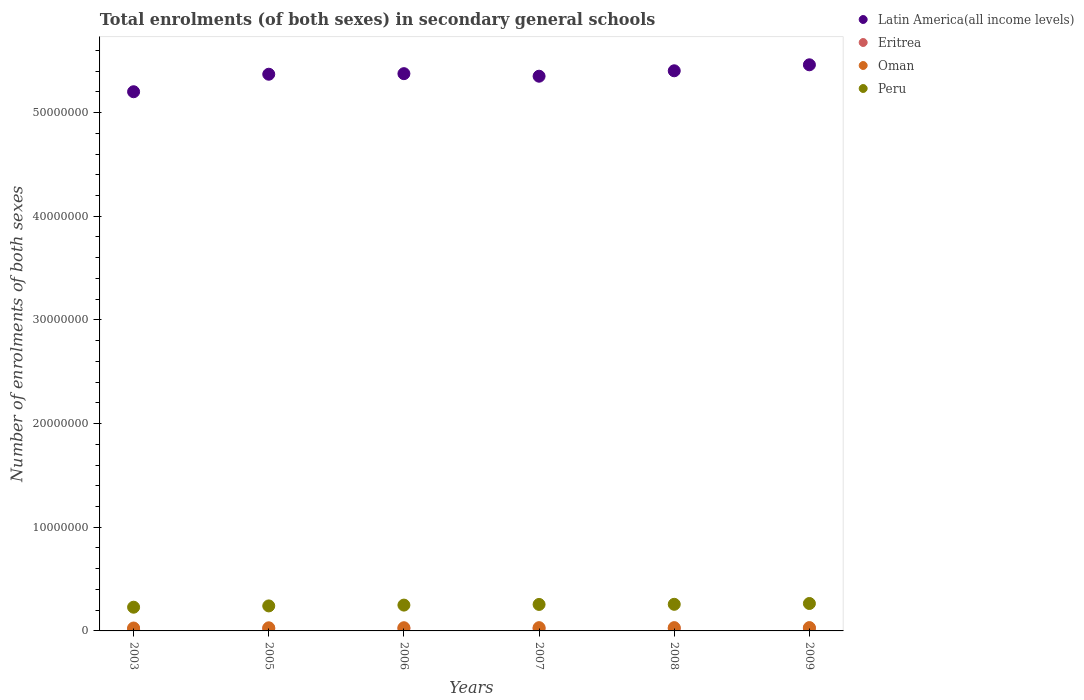How many different coloured dotlines are there?
Offer a very short reply. 4. Is the number of dotlines equal to the number of legend labels?
Provide a succinct answer. Yes. What is the number of enrolments in secondary schools in Eritrea in 2003?
Keep it short and to the point. 1.59e+05. Across all years, what is the maximum number of enrolments in secondary schools in Oman?
Make the answer very short. 3.22e+05. Across all years, what is the minimum number of enrolments in secondary schools in Peru?
Ensure brevity in your answer.  2.29e+06. In which year was the number of enrolments in secondary schools in Latin America(all income levels) maximum?
Offer a terse response. 2009. In which year was the number of enrolments in secondary schools in Latin America(all income levels) minimum?
Offer a terse response. 2003. What is the total number of enrolments in secondary schools in Eritrea in the graph?
Offer a terse response. 1.29e+06. What is the difference between the number of enrolments in secondary schools in Peru in 2003 and that in 2007?
Keep it short and to the point. -2.67e+05. What is the difference between the number of enrolments in secondary schools in Peru in 2006 and the number of enrolments in secondary schools in Oman in 2003?
Offer a very short reply. 2.21e+06. What is the average number of enrolments in secondary schools in Oman per year?
Ensure brevity in your answer.  3.07e+05. In the year 2008, what is the difference between the number of enrolments in secondary schools in Latin America(all income levels) and number of enrolments in secondary schools in Peru?
Your answer should be compact. 5.15e+07. What is the ratio of the number of enrolments in secondary schools in Oman in 2006 to that in 2007?
Your answer should be very brief. 0.98. Is the number of enrolments in secondary schools in Eritrea in 2006 less than that in 2008?
Make the answer very short. Yes. What is the difference between the highest and the second highest number of enrolments in secondary schools in Oman?
Offer a terse response. 3854. What is the difference between the highest and the lowest number of enrolments in secondary schools in Latin America(all income levels)?
Provide a succinct answer. 2.60e+06. In how many years, is the number of enrolments in secondary schools in Oman greater than the average number of enrolments in secondary schools in Oman taken over all years?
Provide a short and direct response. 4. Is it the case that in every year, the sum of the number of enrolments in secondary schools in Oman and number of enrolments in secondary schools in Eritrea  is greater than the sum of number of enrolments in secondary schools in Peru and number of enrolments in secondary schools in Latin America(all income levels)?
Give a very brief answer. No. Is it the case that in every year, the sum of the number of enrolments in secondary schools in Latin America(all income levels) and number of enrolments in secondary schools in Peru  is greater than the number of enrolments in secondary schools in Oman?
Offer a very short reply. Yes. Does the number of enrolments in secondary schools in Latin America(all income levels) monotonically increase over the years?
Provide a succinct answer. No. How many dotlines are there?
Your response must be concise. 4. Are the values on the major ticks of Y-axis written in scientific E-notation?
Your answer should be very brief. No. Does the graph contain any zero values?
Ensure brevity in your answer.  No. Does the graph contain grids?
Give a very brief answer. No. How are the legend labels stacked?
Make the answer very short. Vertical. What is the title of the graph?
Your response must be concise. Total enrolments (of both sexes) in secondary general schools. What is the label or title of the X-axis?
Provide a succinct answer. Years. What is the label or title of the Y-axis?
Provide a short and direct response. Number of enrolments of both sexes. What is the Number of enrolments of both sexes of Latin America(all income levels) in 2003?
Keep it short and to the point. 5.20e+07. What is the Number of enrolments of both sexes of Eritrea in 2003?
Offer a terse response. 1.59e+05. What is the Number of enrolments of both sexes of Oman in 2003?
Give a very brief answer. 2.79e+05. What is the Number of enrolments of both sexes of Peru in 2003?
Make the answer very short. 2.29e+06. What is the Number of enrolments of both sexes in Latin America(all income levels) in 2005?
Make the answer very short. 5.37e+07. What is the Number of enrolments of both sexes in Eritrea in 2005?
Ensure brevity in your answer.  2.15e+05. What is the Number of enrolments of both sexes in Oman in 2005?
Your answer should be very brief. 3.02e+05. What is the Number of enrolments of both sexes in Peru in 2005?
Give a very brief answer. 2.41e+06. What is the Number of enrolments of both sexes of Latin America(all income levels) in 2006?
Make the answer very short. 5.38e+07. What is the Number of enrolments of both sexes of Eritrea in 2006?
Offer a very short reply. 2.26e+05. What is the Number of enrolments of both sexes in Oman in 2006?
Provide a succinct answer. 3.09e+05. What is the Number of enrolments of both sexes in Peru in 2006?
Your answer should be compact. 2.49e+06. What is the Number of enrolments of both sexes of Latin America(all income levels) in 2007?
Your answer should be compact. 5.35e+07. What is the Number of enrolments of both sexes in Eritrea in 2007?
Offer a very short reply. 2.17e+05. What is the Number of enrolments of both sexes in Oman in 2007?
Provide a succinct answer. 3.16e+05. What is the Number of enrolments of both sexes of Peru in 2007?
Provide a short and direct response. 2.55e+06. What is the Number of enrolments of both sexes in Latin America(all income levels) in 2008?
Your response must be concise. 5.40e+07. What is the Number of enrolments of both sexes of Eritrea in 2008?
Offer a very short reply. 2.27e+05. What is the Number of enrolments of both sexes of Oman in 2008?
Provide a short and direct response. 3.18e+05. What is the Number of enrolments of both sexes of Peru in 2008?
Provide a succinct answer. 2.57e+06. What is the Number of enrolments of both sexes of Latin America(all income levels) in 2009?
Ensure brevity in your answer.  5.46e+07. What is the Number of enrolments of both sexes of Eritrea in 2009?
Provide a short and direct response. 2.41e+05. What is the Number of enrolments of both sexes in Oman in 2009?
Your response must be concise. 3.22e+05. What is the Number of enrolments of both sexes of Peru in 2009?
Give a very brief answer. 2.65e+06. Across all years, what is the maximum Number of enrolments of both sexes in Latin America(all income levels)?
Provide a succinct answer. 5.46e+07. Across all years, what is the maximum Number of enrolments of both sexes in Eritrea?
Provide a short and direct response. 2.41e+05. Across all years, what is the maximum Number of enrolments of both sexes in Oman?
Ensure brevity in your answer.  3.22e+05. Across all years, what is the maximum Number of enrolments of both sexes of Peru?
Provide a short and direct response. 2.65e+06. Across all years, what is the minimum Number of enrolments of both sexes in Latin America(all income levels)?
Your answer should be compact. 5.20e+07. Across all years, what is the minimum Number of enrolments of both sexes of Eritrea?
Give a very brief answer. 1.59e+05. Across all years, what is the minimum Number of enrolments of both sexes of Oman?
Give a very brief answer. 2.79e+05. Across all years, what is the minimum Number of enrolments of both sexes of Peru?
Keep it short and to the point. 2.29e+06. What is the total Number of enrolments of both sexes of Latin America(all income levels) in the graph?
Provide a succinct answer. 3.22e+08. What is the total Number of enrolments of both sexes of Eritrea in the graph?
Ensure brevity in your answer.  1.29e+06. What is the total Number of enrolments of both sexes in Oman in the graph?
Offer a very short reply. 1.84e+06. What is the total Number of enrolments of both sexes in Peru in the graph?
Your answer should be very brief. 1.50e+07. What is the difference between the Number of enrolments of both sexes of Latin America(all income levels) in 2003 and that in 2005?
Your response must be concise. -1.69e+06. What is the difference between the Number of enrolments of both sexes of Eritrea in 2003 and that in 2005?
Offer a terse response. -5.56e+04. What is the difference between the Number of enrolments of both sexes in Oman in 2003 and that in 2005?
Make the answer very short. -2.23e+04. What is the difference between the Number of enrolments of both sexes in Peru in 2003 and that in 2005?
Offer a very short reply. -1.25e+05. What is the difference between the Number of enrolments of both sexes in Latin America(all income levels) in 2003 and that in 2006?
Provide a short and direct response. -1.74e+06. What is the difference between the Number of enrolments of both sexes in Eritrea in 2003 and that in 2006?
Your answer should be compact. -6.63e+04. What is the difference between the Number of enrolments of both sexes in Oman in 2003 and that in 2006?
Your answer should be very brief. -2.92e+04. What is the difference between the Number of enrolments of both sexes in Peru in 2003 and that in 2006?
Provide a succinct answer. -2.04e+05. What is the difference between the Number of enrolments of both sexes of Latin America(all income levels) in 2003 and that in 2007?
Offer a very short reply. -1.50e+06. What is the difference between the Number of enrolments of both sexes of Eritrea in 2003 and that in 2007?
Provide a succinct answer. -5.74e+04. What is the difference between the Number of enrolments of both sexes in Oman in 2003 and that in 2007?
Your answer should be very brief. -3.67e+04. What is the difference between the Number of enrolments of both sexes of Peru in 2003 and that in 2007?
Give a very brief answer. -2.67e+05. What is the difference between the Number of enrolments of both sexes of Latin America(all income levels) in 2003 and that in 2008?
Your response must be concise. -2.02e+06. What is the difference between the Number of enrolments of both sexes of Eritrea in 2003 and that in 2008?
Your answer should be very brief. -6.80e+04. What is the difference between the Number of enrolments of both sexes in Oman in 2003 and that in 2008?
Give a very brief answer. -3.85e+04. What is the difference between the Number of enrolments of both sexes of Peru in 2003 and that in 2008?
Ensure brevity in your answer.  -2.79e+05. What is the difference between the Number of enrolments of both sexes of Latin America(all income levels) in 2003 and that in 2009?
Provide a short and direct response. -2.60e+06. What is the difference between the Number of enrolments of both sexes of Eritrea in 2003 and that in 2009?
Your response must be concise. -8.14e+04. What is the difference between the Number of enrolments of both sexes in Oman in 2003 and that in 2009?
Offer a terse response. -4.24e+04. What is the difference between the Number of enrolments of both sexes of Peru in 2003 and that in 2009?
Provide a short and direct response. -3.58e+05. What is the difference between the Number of enrolments of both sexes of Latin America(all income levels) in 2005 and that in 2006?
Offer a terse response. -5.54e+04. What is the difference between the Number of enrolments of both sexes in Eritrea in 2005 and that in 2006?
Offer a terse response. -1.06e+04. What is the difference between the Number of enrolments of both sexes in Oman in 2005 and that in 2006?
Make the answer very short. -6940. What is the difference between the Number of enrolments of both sexes of Peru in 2005 and that in 2006?
Make the answer very short. -7.90e+04. What is the difference between the Number of enrolments of both sexes in Latin America(all income levels) in 2005 and that in 2007?
Your response must be concise. 1.91e+05. What is the difference between the Number of enrolments of both sexes of Eritrea in 2005 and that in 2007?
Your answer should be very brief. -1801. What is the difference between the Number of enrolments of both sexes in Oman in 2005 and that in 2007?
Provide a short and direct response. -1.45e+04. What is the difference between the Number of enrolments of both sexes of Peru in 2005 and that in 2007?
Your answer should be very brief. -1.42e+05. What is the difference between the Number of enrolments of both sexes of Latin America(all income levels) in 2005 and that in 2008?
Offer a very short reply. -3.32e+05. What is the difference between the Number of enrolments of both sexes of Eritrea in 2005 and that in 2008?
Keep it short and to the point. -1.24e+04. What is the difference between the Number of enrolments of both sexes in Oman in 2005 and that in 2008?
Your response must be concise. -1.62e+04. What is the difference between the Number of enrolments of both sexes in Peru in 2005 and that in 2008?
Keep it short and to the point. -1.54e+05. What is the difference between the Number of enrolments of both sexes of Latin America(all income levels) in 2005 and that in 2009?
Provide a succinct answer. -9.10e+05. What is the difference between the Number of enrolments of both sexes of Eritrea in 2005 and that in 2009?
Ensure brevity in your answer.  -2.58e+04. What is the difference between the Number of enrolments of both sexes of Oman in 2005 and that in 2009?
Make the answer very short. -2.01e+04. What is the difference between the Number of enrolments of both sexes in Peru in 2005 and that in 2009?
Offer a very short reply. -2.33e+05. What is the difference between the Number of enrolments of both sexes of Latin America(all income levels) in 2006 and that in 2007?
Your response must be concise. 2.46e+05. What is the difference between the Number of enrolments of both sexes of Eritrea in 2006 and that in 2007?
Provide a succinct answer. 8845. What is the difference between the Number of enrolments of both sexes in Oman in 2006 and that in 2007?
Ensure brevity in your answer.  -7511. What is the difference between the Number of enrolments of both sexes in Peru in 2006 and that in 2007?
Provide a succinct answer. -6.28e+04. What is the difference between the Number of enrolments of both sexes in Latin America(all income levels) in 2006 and that in 2008?
Give a very brief answer. -2.77e+05. What is the difference between the Number of enrolments of both sexes of Eritrea in 2006 and that in 2008?
Offer a terse response. -1716. What is the difference between the Number of enrolments of both sexes of Oman in 2006 and that in 2008?
Offer a very short reply. -9308. What is the difference between the Number of enrolments of both sexes of Peru in 2006 and that in 2008?
Offer a very short reply. -7.54e+04. What is the difference between the Number of enrolments of both sexes in Latin America(all income levels) in 2006 and that in 2009?
Make the answer very short. -8.55e+05. What is the difference between the Number of enrolments of both sexes of Eritrea in 2006 and that in 2009?
Offer a terse response. -1.52e+04. What is the difference between the Number of enrolments of both sexes of Oman in 2006 and that in 2009?
Give a very brief answer. -1.32e+04. What is the difference between the Number of enrolments of both sexes in Peru in 2006 and that in 2009?
Make the answer very short. -1.54e+05. What is the difference between the Number of enrolments of both sexes in Latin America(all income levels) in 2007 and that in 2008?
Provide a short and direct response. -5.23e+05. What is the difference between the Number of enrolments of both sexes in Eritrea in 2007 and that in 2008?
Ensure brevity in your answer.  -1.06e+04. What is the difference between the Number of enrolments of both sexes of Oman in 2007 and that in 2008?
Your answer should be compact. -1797. What is the difference between the Number of enrolments of both sexes in Peru in 2007 and that in 2008?
Make the answer very short. -1.26e+04. What is the difference between the Number of enrolments of both sexes of Latin America(all income levels) in 2007 and that in 2009?
Your answer should be very brief. -1.10e+06. What is the difference between the Number of enrolments of both sexes in Eritrea in 2007 and that in 2009?
Give a very brief answer. -2.40e+04. What is the difference between the Number of enrolments of both sexes of Oman in 2007 and that in 2009?
Offer a terse response. -5651. What is the difference between the Number of enrolments of both sexes in Peru in 2007 and that in 2009?
Offer a very short reply. -9.13e+04. What is the difference between the Number of enrolments of both sexes in Latin America(all income levels) in 2008 and that in 2009?
Your answer should be compact. -5.78e+05. What is the difference between the Number of enrolments of both sexes of Eritrea in 2008 and that in 2009?
Provide a succinct answer. -1.34e+04. What is the difference between the Number of enrolments of both sexes in Oman in 2008 and that in 2009?
Ensure brevity in your answer.  -3854. What is the difference between the Number of enrolments of both sexes of Peru in 2008 and that in 2009?
Make the answer very short. -7.87e+04. What is the difference between the Number of enrolments of both sexes of Latin America(all income levels) in 2003 and the Number of enrolments of both sexes of Eritrea in 2005?
Make the answer very short. 5.18e+07. What is the difference between the Number of enrolments of both sexes in Latin America(all income levels) in 2003 and the Number of enrolments of both sexes in Oman in 2005?
Your answer should be compact. 5.17e+07. What is the difference between the Number of enrolments of both sexes of Latin America(all income levels) in 2003 and the Number of enrolments of both sexes of Peru in 2005?
Your answer should be compact. 4.96e+07. What is the difference between the Number of enrolments of both sexes in Eritrea in 2003 and the Number of enrolments of both sexes in Oman in 2005?
Ensure brevity in your answer.  -1.42e+05. What is the difference between the Number of enrolments of both sexes of Eritrea in 2003 and the Number of enrolments of both sexes of Peru in 2005?
Your answer should be compact. -2.25e+06. What is the difference between the Number of enrolments of both sexes of Oman in 2003 and the Number of enrolments of both sexes of Peru in 2005?
Ensure brevity in your answer.  -2.13e+06. What is the difference between the Number of enrolments of both sexes of Latin America(all income levels) in 2003 and the Number of enrolments of both sexes of Eritrea in 2006?
Give a very brief answer. 5.18e+07. What is the difference between the Number of enrolments of both sexes of Latin America(all income levels) in 2003 and the Number of enrolments of both sexes of Oman in 2006?
Provide a succinct answer. 5.17e+07. What is the difference between the Number of enrolments of both sexes of Latin America(all income levels) in 2003 and the Number of enrolments of both sexes of Peru in 2006?
Keep it short and to the point. 4.95e+07. What is the difference between the Number of enrolments of both sexes of Eritrea in 2003 and the Number of enrolments of both sexes of Oman in 2006?
Your answer should be compact. -1.49e+05. What is the difference between the Number of enrolments of both sexes of Eritrea in 2003 and the Number of enrolments of both sexes of Peru in 2006?
Offer a very short reply. -2.33e+06. What is the difference between the Number of enrolments of both sexes of Oman in 2003 and the Number of enrolments of both sexes of Peru in 2006?
Make the answer very short. -2.21e+06. What is the difference between the Number of enrolments of both sexes in Latin America(all income levels) in 2003 and the Number of enrolments of both sexes in Eritrea in 2007?
Make the answer very short. 5.18e+07. What is the difference between the Number of enrolments of both sexes of Latin America(all income levels) in 2003 and the Number of enrolments of both sexes of Oman in 2007?
Offer a terse response. 5.17e+07. What is the difference between the Number of enrolments of both sexes in Latin America(all income levels) in 2003 and the Number of enrolments of both sexes in Peru in 2007?
Provide a short and direct response. 4.95e+07. What is the difference between the Number of enrolments of both sexes of Eritrea in 2003 and the Number of enrolments of both sexes of Oman in 2007?
Give a very brief answer. -1.57e+05. What is the difference between the Number of enrolments of both sexes of Eritrea in 2003 and the Number of enrolments of both sexes of Peru in 2007?
Your answer should be compact. -2.39e+06. What is the difference between the Number of enrolments of both sexes in Oman in 2003 and the Number of enrolments of both sexes in Peru in 2007?
Give a very brief answer. -2.27e+06. What is the difference between the Number of enrolments of both sexes of Latin America(all income levels) in 2003 and the Number of enrolments of both sexes of Eritrea in 2008?
Offer a terse response. 5.18e+07. What is the difference between the Number of enrolments of both sexes in Latin America(all income levels) in 2003 and the Number of enrolments of both sexes in Oman in 2008?
Provide a short and direct response. 5.17e+07. What is the difference between the Number of enrolments of both sexes of Latin America(all income levels) in 2003 and the Number of enrolments of both sexes of Peru in 2008?
Keep it short and to the point. 4.94e+07. What is the difference between the Number of enrolments of both sexes of Eritrea in 2003 and the Number of enrolments of both sexes of Oman in 2008?
Provide a short and direct response. -1.58e+05. What is the difference between the Number of enrolments of both sexes of Eritrea in 2003 and the Number of enrolments of both sexes of Peru in 2008?
Provide a succinct answer. -2.41e+06. What is the difference between the Number of enrolments of both sexes in Oman in 2003 and the Number of enrolments of both sexes in Peru in 2008?
Give a very brief answer. -2.29e+06. What is the difference between the Number of enrolments of both sexes in Latin America(all income levels) in 2003 and the Number of enrolments of both sexes in Eritrea in 2009?
Your answer should be very brief. 5.18e+07. What is the difference between the Number of enrolments of both sexes in Latin America(all income levels) in 2003 and the Number of enrolments of both sexes in Oman in 2009?
Offer a very short reply. 5.17e+07. What is the difference between the Number of enrolments of both sexes in Latin America(all income levels) in 2003 and the Number of enrolments of both sexes in Peru in 2009?
Make the answer very short. 4.94e+07. What is the difference between the Number of enrolments of both sexes in Eritrea in 2003 and the Number of enrolments of both sexes in Oman in 2009?
Your answer should be very brief. -1.62e+05. What is the difference between the Number of enrolments of both sexes of Eritrea in 2003 and the Number of enrolments of both sexes of Peru in 2009?
Offer a terse response. -2.49e+06. What is the difference between the Number of enrolments of both sexes in Oman in 2003 and the Number of enrolments of both sexes in Peru in 2009?
Your answer should be compact. -2.37e+06. What is the difference between the Number of enrolments of both sexes of Latin America(all income levels) in 2005 and the Number of enrolments of both sexes of Eritrea in 2006?
Provide a succinct answer. 5.35e+07. What is the difference between the Number of enrolments of both sexes of Latin America(all income levels) in 2005 and the Number of enrolments of both sexes of Oman in 2006?
Offer a very short reply. 5.34e+07. What is the difference between the Number of enrolments of both sexes of Latin America(all income levels) in 2005 and the Number of enrolments of both sexes of Peru in 2006?
Offer a terse response. 5.12e+07. What is the difference between the Number of enrolments of both sexes in Eritrea in 2005 and the Number of enrolments of both sexes in Oman in 2006?
Offer a very short reply. -9.34e+04. What is the difference between the Number of enrolments of both sexes of Eritrea in 2005 and the Number of enrolments of both sexes of Peru in 2006?
Your answer should be very brief. -2.28e+06. What is the difference between the Number of enrolments of both sexes in Oman in 2005 and the Number of enrolments of both sexes in Peru in 2006?
Make the answer very short. -2.19e+06. What is the difference between the Number of enrolments of both sexes in Latin America(all income levels) in 2005 and the Number of enrolments of both sexes in Eritrea in 2007?
Your response must be concise. 5.35e+07. What is the difference between the Number of enrolments of both sexes of Latin America(all income levels) in 2005 and the Number of enrolments of both sexes of Oman in 2007?
Give a very brief answer. 5.34e+07. What is the difference between the Number of enrolments of both sexes of Latin America(all income levels) in 2005 and the Number of enrolments of both sexes of Peru in 2007?
Provide a succinct answer. 5.11e+07. What is the difference between the Number of enrolments of both sexes in Eritrea in 2005 and the Number of enrolments of both sexes in Oman in 2007?
Your response must be concise. -1.01e+05. What is the difference between the Number of enrolments of both sexes of Eritrea in 2005 and the Number of enrolments of both sexes of Peru in 2007?
Offer a terse response. -2.34e+06. What is the difference between the Number of enrolments of both sexes in Oman in 2005 and the Number of enrolments of both sexes in Peru in 2007?
Provide a short and direct response. -2.25e+06. What is the difference between the Number of enrolments of both sexes in Latin America(all income levels) in 2005 and the Number of enrolments of both sexes in Eritrea in 2008?
Ensure brevity in your answer.  5.35e+07. What is the difference between the Number of enrolments of both sexes of Latin America(all income levels) in 2005 and the Number of enrolments of both sexes of Oman in 2008?
Ensure brevity in your answer.  5.34e+07. What is the difference between the Number of enrolments of both sexes of Latin America(all income levels) in 2005 and the Number of enrolments of both sexes of Peru in 2008?
Ensure brevity in your answer.  5.11e+07. What is the difference between the Number of enrolments of both sexes in Eritrea in 2005 and the Number of enrolments of both sexes in Oman in 2008?
Provide a succinct answer. -1.03e+05. What is the difference between the Number of enrolments of both sexes in Eritrea in 2005 and the Number of enrolments of both sexes in Peru in 2008?
Keep it short and to the point. -2.35e+06. What is the difference between the Number of enrolments of both sexes of Oman in 2005 and the Number of enrolments of both sexes of Peru in 2008?
Ensure brevity in your answer.  -2.27e+06. What is the difference between the Number of enrolments of both sexes in Latin America(all income levels) in 2005 and the Number of enrolments of both sexes in Eritrea in 2009?
Your answer should be very brief. 5.35e+07. What is the difference between the Number of enrolments of both sexes in Latin America(all income levels) in 2005 and the Number of enrolments of both sexes in Oman in 2009?
Your answer should be very brief. 5.34e+07. What is the difference between the Number of enrolments of both sexes in Latin America(all income levels) in 2005 and the Number of enrolments of both sexes in Peru in 2009?
Provide a short and direct response. 5.11e+07. What is the difference between the Number of enrolments of both sexes in Eritrea in 2005 and the Number of enrolments of both sexes in Oman in 2009?
Your answer should be very brief. -1.07e+05. What is the difference between the Number of enrolments of both sexes of Eritrea in 2005 and the Number of enrolments of both sexes of Peru in 2009?
Provide a short and direct response. -2.43e+06. What is the difference between the Number of enrolments of both sexes of Oman in 2005 and the Number of enrolments of both sexes of Peru in 2009?
Give a very brief answer. -2.34e+06. What is the difference between the Number of enrolments of both sexes in Latin America(all income levels) in 2006 and the Number of enrolments of both sexes in Eritrea in 2007?
Your response must be concise. 5.35e+07. What is the difference between the Number of enrolments of both sexes of Latin America(all income levels) in 2006 and the Number of enrolments of both sexes of Oman in 2007?
Offer a terse response. 5.34e+07. What is the difference between the Number of enrolments of both sexes in Latin America(all income levels) in 2006 and the Number of enrolments of both sexes in Peru in 2007?
Your answer should be very brief. 5.12e+07. What is the difference between the Number of enrolments of both sexes in Eritrea in 2006 and the Number of enrolments of both sexes in Oman in 2007?
Provide a succinct answer. -9.03e+04. What is the difference between the Number of enrolments of both sexes in Eritrea in 2006 and the Number of enrolments of both sexes in Peru in 2007?
Give a very brief answer. -2.33e+06. What is the difference between the Number of enrolments of both sexes of Oman in 2006 and the Number of enrolments of both sexes of Peru in 2007?
Provide a succinct answer. -2.25e+06. What is the difference between the Number of enrolments of both sexes in Latin America(all income levels) in 2006 and the Number of enrolments of both sexes in Eritrea in 2008?
Provide a short and direct response. 5.35e+07. What is the difference between the Number of enrolments of both sexes in Latin America(all income levels) in 2006 and the Number of enrolments of both sexes in Oman in 2008?
Ensure brevity in your answer.  5.34e+07. What is the difference between the Number of enrolments of both sexes in Latin America(all income levels) in 2006 and the Number of enrolments of both sexes in Peru in 2008?
Provide a short and direct response. 5.12e+07. What is the difference between the Number of enrolments of both sexes of Eritrea in 2006 and the Number of enrolments of both sexes of Oman in 2008?
Ensure brevity in your answer.  -9.21e+04. What is the difference between the Number of enrolments of both sexes of Eritrea in 2006 and the Number of enrolments of both sexes of Peru in 2008?
Offer a very short reply. -2.34e+06. What is the difference between the Number of enrolments of both sexes in Oman in 2006 and the Number of enrolments of both sexes in Peru in 2008?
Ensure brevity in your answer.  -2.26e+06. What is the difference between the Number of enrolments of both sexes of Latin America(all income levels) in 2006 and the Number of enrolments of both sexes of Eritrea in 2009?
Your answer should be very brief. 5.35e+07. What is the difference between the Number of enrolments of both sexes of Latin America(all income levels) in 2006 and the Number of enrolments of both sexes of Oman in 2009?
Provide a succinct answer. 5.34e+07. What is the difference between the Number of enrolments of both sexes in Latin America(all income levels) in 2006 and the Number of enrolments of both sexes in Peru in 2009?
Your answer should be compact. 5.11e+07. What is the difference between the Number of enrolments of both sexes of Eritrea in 2006 and the Number of enrolments of both sexes of Oman in 2009?
Give a very brief answer. -9.59e+04. What is the difference between the Number of enrolments of both sexes in Eritrea in 2006 and the Number of enrolments of both sexes in Peru in 2009?
Provide a succinct answer. -2.42e+06. What is the difference between the Number of enrolments of both sexes in Oman in 2006 and the Number of enrolments of both sexes in Peru in 2009?
Keep it short and to the point. -2.34e+06. What is the difference between the Number of enrolments of both sexes of Latin America(all income levels) in 2007 and the Number of enrolments of both sexes of Eritrea in 2008?
Your answer should be compact. 5.33e+07. What is the difference between the Number of enrolments of both sexes in Latin America(all income levels) in 2007 and the Number of enrolments of both sexes in Oman in 2008?
Give a very brief answer. 5.32e+07. What is the difference between the Number of enrolments of both sexes of Latin America(all income levels) in 2007 and the Number of enrolments of both sexes of Peru in 2008?
Keep it short and to the point. 5.09e+07. What is the difference between the Number of enrolments of both sexes in Eritrea in 2007 and the Number of enrolments of both sexes in Oman in 2008?
Your response must be concise. -1.01e+05. What is the difference between the Number of enrolments of both sexes of Eritrea in 2007 and the Number of enrolments of both sexes of Peru in 2008?
Offer a terse response. -2.35e+06. What is the difference between the Number of enrolments of both sexes in Oman in 2007 and the Number of enrolments of both sexes in Peru in 2008?
Keep it short and to the point. -2.25e+06. What is the difference between the Number of enrolments of both sexes of Latin America(all income levels) in 2007 and the Number of enrolments of both sexes of Eritrea in 2009?
Provide a succinct answer. 5.33e+07. What is the difference between the Number of enrolments of both sexes in Latin America(all income levels) in 2007 and the Number of enrolments of both sexes in Oman in 2009?
Provide a short and direct response. 5.32e+07. What is the difference between the Number of enrolments of both sexes of Latin America(all income levels) in 2007 and the Number of enrolments of both sexes of Peru in 2009?
Make the answer very short. 5.09e+07. What is the difference between the Number of enrolments of both sexes of Eritrea in 2007 and the Number of enrolments of both sexes of Oman in 2009?
Your response must be concise. -1.05e+05. What is the difference between the Number of enrolments of both sexes in Eritrea in 2007 and the Number of enrolments of both sexes in Peru in 2009?
Keep it short and to the point. -2.43e+06. What is the difference between the Number of enrolments of both sexes in Oman in 2007 and the Number of enrolments of both sexes in Peru in 2009?
Your answer should be compact. -2.33e+06. What is the difference between the Number of enrolments of both sexes of Latin America(all income levels) in 2008 and the Number of enrolments of both sexes of Eritrea in 2009?
Keep it short and to the point. 5.38e+07. What is the difference between the Number of enrolments of both sexes of Latin America(all income levels) in 2008 and the Number of enrolments of both sexes of Oman in 2009?
Make the answer very short. 5.37e+07. What is the difference between the Number of enrolments of both sexes in Latin America(all income levels) in 2008 and the Number of enrolments of both sexes in Peru in 2009?
Offer a very short reply. 5.14e+07. What is the difference between the Number of enrolments of both sexes of Eritrea in 2008 and the Number of enrolments of both sexes of Oman in 2009?
Your answer should be compact. -9.42e+04. What is the difference between the Number of enrolments of both sexes in Eritrea in 2008 and the Number of enrolments of both sexes in Peru in 2009?
Make the answer very short. -2.42e+06. What is the difference between the Number of enrolments of both sexes in Oman in 2008 and the Number of enrolments of both sexes in Peru in 2009?
Offer a terse response. -2.33e+06. What is the average Number of enrolments of both sexes in Latin America(all income levels) per year?
Provide a succinct answer. 5.36e+07. What is the average Number of enrolments of both sexes in Eritrea per year?
Your answer should be compact. 2.14e+05. What is the average Number of enrolments of both sexes in Oman per year?
Keep it short and to the point. 3.07e+05. What is the average Number of enrolments of both sexes in Peru per year?
Offer a very short reply. 2.49e+06. In the year 2003, what is the difference between the Number of enrolments of both sexes in Latin America(all income levels) and Number of enrolments of both sexes in Eritrea?
Your response must be concise. 5.18e+07. In the year 2003, what is the difference between the Number of enrolments of both sexes in Latin America(all income levels) and Number of enrolments of both sexes in Oman?
Offer a very short reply. 5.17e+07. In the year 2003, what is the difference between the Number of enrolments of both sexes in Latin America(all income levels) and Number of enrolments of both sexes in Peru?
Provide a short and direct response. 4.97e+07. In the year 2003, what is the difference between the Number of enrolments of both sexes of Eritrea and Number of enrolments of both sexes of Oman?
Your answer should be very brief. -1.20e+05. In the year 2003, what is the difference between the Number of enrolments of both sexes in Eritrea and Number of enrolments of both sexes in Peru?
Give a very brief answer. -2.13e+06. In the year 2003, what is the difference between the Number of enrolments of both sexes in Oman and Number of enrolments of both sexes in Peru?
Provide a short and direct response. -2.01e+06. In the year 2005, what is the difference between the Number of enrolments of both sexes of Latin America(all income levels) and Number of enrolments of both sexes of Eritrea?
Give a very brief answer. 5.35e+07. In the year 2005, what is the difference between the Number of enrolments of both sexes of Latin America(all income levels) and Number of enrolments of both sexes of Oman?
Provide a short and direct response. 5.34e+07. In the year 2005, what is the difference between the Number of enrolments of both sexes of Latin America(all income levels) and Number of enrolments of both sexes of Peru?
Ensure brevity in your answer.  5.13e+07. In the year 2005, what is the difference between the Number of enrolments of both sexes of Eritrea and Number of enrolments of both sexes of Oman?
Offer a very short reply. -8.65e+04. In the year 2005, what is the difference between the Number of enrolments of both sexes in Eritrea and Number of enrolments of both sexes in Peru?
Provide a succinct answer. -2.20e+06. In the year 2005, what is the difference between the Number of enrolments of both sexes of Oman and Number of enrolments of both sexes of Peru?
Your answer should be compact. -2.11e+06. In the year 2006, what is the difference between the Number of enrolments of both sexes in Latin America(all income levels) and Number of enrolments of both sexes in Eritrea?
Offer a very short reply. 5.35e+07. In the year 2006, what is the difference between the Number of enrolments of both sexes in Latin America(all income levels) and Number of enrolments of both sexes in Oman?
Your response must be concise. 5.34e+07. In the year 2006, what is the difference between the Number of enrolments of both sexes of Latin America(all income levels) and Number of enrolments of both sexes of Peru?
Provide a short and direct response. 5.13e+07. In the year 2006, what is the difference between the Number of enrolments of both sexes of Eritrea and Number of enrolments of both sexes of Oman?
Offer a very short reply. -8.28e+04. In the year 2006, what is the difference between the Number of enrolments of both sexes in Eritrea and Number of enrolments of both sexes in Peru?
Your answer should be compact. -2.27e+06. In the year 2006, what is the difference between the Number of enrolments of both sexes of Oman and Number of enrolments of both sexes of Peru?
Your response must be concise. -2.18e+06. In the year 2007, what is the difference between the Number of enrolments of both sexes in Latin America(all income levels) and Number of enrolments of both sexes in Eritrea?
Provide a short and direct response. 5.33e+07. In the year 2007, what is the difference between the Number of enrolments of both sexes in Latin America(all income levels) and Number of enrolments of both sexes in Oman?
Your answer should be compact. 5.32e+07. In the year 2007, what is the difference between the Number of enrolments of both sexes in Latin America(all income levels) and Number of enrolments of both sexes in Peru?
Provide a short and direct response. 5.10e+07. In the year 2007, what is the difference between the Number of enrolments of both sexes of Eritrea and Number of enrolments of both sexes of Oman?
Offer a very short reply. -9.91e+04. In the year 2007, what is the difference between the Number of enrolments of both sexes in Eritrea and Number of enrolments of both sexes in Peru?
Make the answer very short. -2.34e+06. In the year 2007, what is the difference between the Number of enrolments of both sexes of Oman and Number of enrolments of both sexes of Peru?
Give a very brief answer. -2.24e+06. In the year 2008, what is the difference between the Number of enrolments of both sexes of Latin America(all income levels) and Number of enrolments of both sexes of Eritrea?
Ensure brevity in your answer.  5.38e+07. In the year 2008, what is the difference between the Number of enrolments of both sexes of Latin America(all income levels) and Number of enrolments of both sexes of Oman?
Make the answer very short. 5.37e+07. In the year 2008, what is the difference between the Number of enrolments of both sexes of Latin America(all income levels) and Number of enrolments of both sexes of Peru?
Provide a succinct answer. 5.15e+07. In the year 2008, what is the difference between the Number of enrolments of both sexes in Eritrea and Number of enrolments of both sexes in Oman?
Provide a short and direct response. -9.04e+04. In the year 2008, what is the difference between the Number of enrolments of both sexes in Eritrea and Number of enrolments of both sexes in Peru?
Make the answer very short. -2.34e+06. In the year 2008, what is the difference between the Number of enrolments of both sexes in Oman and Number of enrolments of both sexes in Peru?
Offer a terse response. -2.25e+06. In the year 2009, what is the difference between the Number of enrolments of both sexes of Latin America(all income levels) and Number of enrolments of both sexes of Eritrea?
Make the answer very short. 5.44e+07. In the year 2009, what is the difference between the Number of enrolments of both sexes of Latin America(all income levels) and Number of enrolments of both sexes of Oman?
Make the answer very short. 5.43e+07. In the year 2009, what is the difference between the Number of enrolments of both sexes of Latin America(all income levels) and Number of enrolments of both sexes of Peru?
Provide a short and direct response. 5.20e+07. In the year 2009, what is the difference between the Number of enrolments of both sexes of Eritrea and Number of enrolments of both sexes of Oman?
Offer a very short reply. -8.08e+04. In the year 2009, what is the difference between the Number of enrolments of both sexes in Eritrea and Number of enrolments of both sexes in Peru?
Your answer should be very brief. -2.40e+06. In the year 2009, what is the difference between the Number of enrolments of both sexes in Oman and Number of enrolments of both sexes in Peru?
Your answer should be very brief. -2.32e+06. What is the ratio of the Number of enrolments of both sexes of Latin America(all income levels) in 2003 to that in 2005?
Offer a terse response. 0.97. What is the ratio of the Number of enrolments of both sexes in Eritrea in 2003 to that in 2005?
Keep it short and to the point. 0.74. What is the ratio of the Number of enrolments of both sexes in Oman in 2003 to that in 2005?
Your answer should be very brief. 0.93. What is the ratio of the Number of enrolments of both sexes of Peru in 2003 to that in 2005?
Your response must be concise. 0.95. What is the ratio of the Number of enrolments of both sexes of Latin America(all income levels) in 2003 to that in 2006?
Offer a very short reply. 0.97. What is the ratio of the Number of enrolments of both sexes of Eritrea in 2003 to that in 2006?
Offer a terse response. 0.71. What is the ratio of the Number of enrolments of both sexes of Oman in 2003 to that in 2006?
Provide a short and direct response. 0.91. What is the ratio of the Number of enrolments of both sexes in Peru in 2003 to that in 2006?
Your response must be concise. 0.92. What is the ratio of the Number of enrolments of both sexes of Latin America(all income levels) in 2003 to that in 2007?
Keep it short and to the point. 0.97. What is the ratio of the Number of enrolments of both sexes in Eritrea in 2003 to that in 2007?
Ensure brevity in your answer.  0.74. What is the ratio of the Number of enrolments of both sexes in Oman in 2003 to that in 2007?
Keep it short and to the point. 0.88. What is the ratio of the Number of enrolments of both sexes of Peru in 2003 to that in 2007?
Offer a very short reply. 0.9. What is the ratio of the Number of enrolments of both sexes of Latin America(all income levels) in 2003 to that in 2008?
Offer a terse response. 0.96. What is the ratio of the Number of enrolments of both sexes in Eritrea in 2003 to that in 2008?
Your answer should be compact. 0.7. What is the ratio of the Number of enrolments of both sexes of Oman in 2003 to that in 2008?
Ensure brevity in your answer.  0.88. What is the ratio of the Number of enrolments of both sexes in Peru in 2003 to that in 2008?
Keep it short and to the point. 0.89. What is the ratio of the Number of enrolments of both sexes of Eritrea in 2003 to that in 2009?
Your answer should be very brief. 0.66. What is the ratio of the Number of enrolments of both sexes in Oman in 2003 to that in 2009?
Ensure brevity in your answer.  0.87. What is the ratio of the Number of enrolments of both sexes in Peru in 2003 to that in 2009?
Your answer should be compact. 0.86. What is the ratio of the Number of enrolments of both sexes in Latin America(all income levels) in 2005 to that in 2006?
Provide a short and direct response. 1. What is the ratio of the Number of enrolments of both sexes of Eritrea in 2005 to that in 2006?
Your answer should be very brief. 0.95. What is the ratio of the Number of enrolments of both sexes in Oman in 2005 to that in 2006?
Give a very brief answer. 0.98. What is the ratio of the Number of enrolments of both sexes of Peru in 2005 to that in 2006?
Provide a short and direct response. 0.97. What is the ratio of the Number of enrolments of both sexes of Latin America(all income levels) in 2005 to that in 2007?
Offer a terse response. 1. What is the ratio of the Number of enrolments of both sexes of Oman in 2005 to that in 2007?
Provide a succinct answer. 0.95. What is the ratio of the Number of enrolments of both sexes in Peru in 2005 to that in 2007?
Provide a short and direct response. 0.94. What is the ratio of the Number of enrolments of both sexes of Latin America(all income levels) in 2005 to that in 2008?
Give a very brief answer. 0.99. What is the ratio of the Number of enrolments of both sexes of Eritrea in 2005 to that in 2008?
Offer a terse response. 0.95. What is the ratio of the Number of enrolments of both sexes in Oman in 2005 to that in 2008?
Keep it short and to the point. 0.95. What is the ratio of the Number of enrolments of both sexes of Peru in 2005 to that in 2008?
Provide a succinct answer. 0.94. What is the ratio of the Number of enrolments of both sexes in Latin America(all income levels) in 2005 to that in 2009?
Provide a short and direct response. 0.98. What is the ratio of the Number of enrolments of both sexes in Eritrea in 2005 to that in 2009?
Your response must be concise. 0.89. What is the ratio of the Number of enrolments of both sexes in Oman in 2005 to that in 2009?
Give a very brief answer. 0.94. What is the ratio of the Number of enrolments of both sexes in Peru in 2005 to that in 2009?
Offer a terse response. 0.91. What is the ratio of the Number of enrolments of both sexes in Latin America(all income levels) in 2006 to that in 2007?
Make the answer very short. 1. What is the ratio of the Number of enrolments of both sexes in Eritrea in 2006 to that in 2007?
Offer a terse response. 1.04. What is the ratio of the Number of enrolments of both sexes of Oman in 2006 to that in 2007?
Give a very brief answer. 0.98. What is the ratio of the Number of enrolments of both sexes in Peru in 2006 to that in 2007?
Keep it short and to the point. 0.98. What is the ratio of the Number of enrolments of both sexes in Latin America(all income levels) in 2006 to that in 2008?
Give a very brief answer. 0.99. What is the ratio of the Number of enrolments of both sexes of Oman in 2006 to that in 2008?
Give a very brief answer. 0.97. What is the ratio of the Number of enrolments of both sexes in Peru in 2006 to that in 2008?
Keep it short and to the point. 0.97. What is the ratio of the Number of enrolments of both sexes of Latin America(all income levels) in 2006 to that in 2009?
Your response must be concise. 0.98. What is the ratio of the Number of enrolments of both sexes of Eritrea in 2006 to that in 2009?
Give a very brief answer. 0.94. What is the ratio of the Number of enrolments of both sexes in Oman in 2006 to that in 2009?
Provide a short and direct response. 0.96. What is the ratio of the Number of enrolments of both sexes of Peru in 2006 to that in 2009?
Give a very brief answer. 0.94. What is the ratio of the Number of enrolments of both sexes in Latin America(all income levels) in 2007 to that in 2008?
Your answer should be very brief. 0.99. What is the ratio of the Number of enrolments of both sexes in Eritrea in 2007 to that in 2008?
Provide a succinct answer. 0.95. What is the ratio of the Number of enrolments of both sexes of Oman in 2007 to that in 2008?
Offer a very short reply. 0.99. What is the ratio of the Number of enrolments of both sexes in Latin America(all income levels) in 2007 to that in 2009?
Make the answer very short. 0.98. What is the ratio of the Number of enrolments of both sexes of Eritrea in 2007 to that in 2009?
Provide a short and direct response. 0.9. What is the ratio of the Number of enrolments of both sexes in Oman in 2007 to that in 2009?
Offer a very short reply. 0.98. What is the ratio of the Number of enrolments of both sexes in Peru in 2007 to that in 2009?
Keep it short and to the point. 0.97. What is the ratio of the Number of enrolments of both sexes in Eritrea in 2008 to that in 2009?
Ensure brevity in your answer.  0.94. What is the ratio of the Number of enrolments of both sexes in Peru in 2008 to that in 2009?
Make the answer very short. 0.97. What is the difference between the highest and the second highest Number of enrolments of both sexes of Latin America(all income levels)?
Your answer should be very brief. 5.78e+05. What is the difference between the highest and the second highest Number of enrolments of both sexes of Eritrea?
Ensure brevity in your answer.  1.34e+04. What is the difference between the highest and the second highest Number of enrolments of both sexes of Oman?
Make the answer very short. 3854. What is the difference between the highest and the second highest Number of enrolments of both sexes of Peru?
Your response must be concise. 7.87e+04. What is the difference between the highest and the lowest Number of enrolments of both sexes in Latin America(all income levels)?
Give a very brief answer. 2.60e+06. What is the difference between the highest and the lowest Number of enrolments of both sexes of Eritrea?
Your answer should be compact. 8.14e+04. What is the difference between the highest and the lowest Number of enrolments of both sexes in Oman?
Make the answer very short. 4.24e+04. What is the difference between the highest and the lowest Number of enrolments of both sexes in Peru?
Provide a succinct answer. 3.58e+05. 